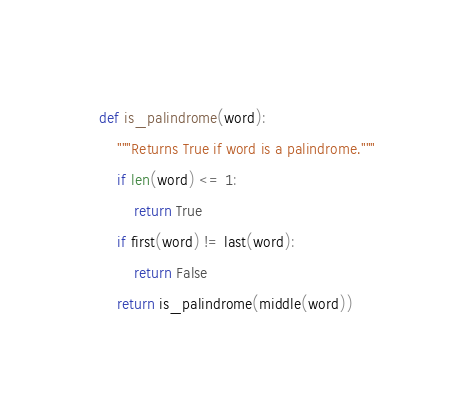<code> <loc_0><loc_0><loc_500><loc_500><_Python_>def is_palindrome(word):
    """Returns True if word is a palindrome."""
    if len(word) <= 1:
        return True
    if first(word) != last(word):
        return False
    return is_palindrome(middle(word))

</code> 